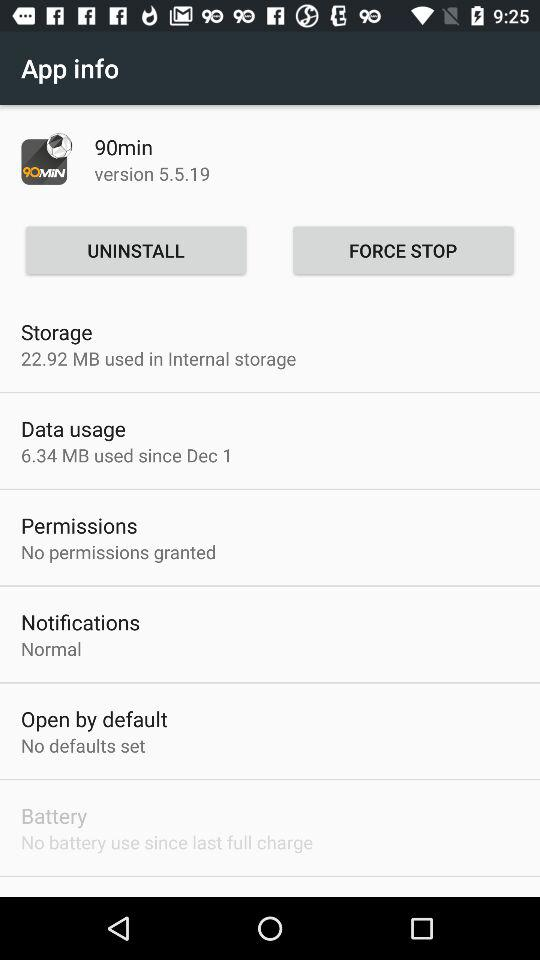What is the version? The version is 5.5.19. 